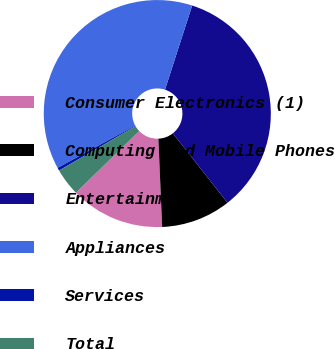<chart> <loc_0><loc_0><loc_500><loc_500><pie_chart><fcel>Consumer Electronics (1)<fcel>Computing and Mobile Phones<fcel>Entertainment<fcel>Appliances<fcel>Services<fcel>Total<nl><fcel>13.41%<fcel>9.93%<fcel>34.42%<fcel>37.91%<fcel>0.42%<fcel>3.91%<nl></chart> 